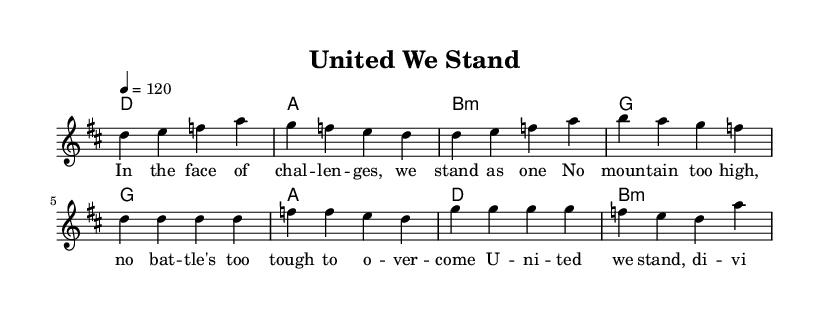What is the key signature of this music? The key signature shown at the beginning of the score is D major, which has two sharps (F# and C#).
Answer: D major What is the time signature of this music? The time signature is indicated in the measure at the start of the music, showing that it is in 4/4 time. This means there are four beats in each measure.
Answer: 4/4 What is the tempo marking for this piece? The tempo is marked as quarter note equals 120, indicating the speed at which the music should be played.
Answer: 120 What is the first chord in the verse? The first chord in the verse section is D, as shown in the chord mode right before the melody starts.
Answer: D How many measures are in the verse? The verse consists of four measures, as indicated by the melody and chord progressions notated within the verse section.
Answer: 4 What themes are addressed in the lyrics? The lyrics mention themes of challenges and unity, expressing the message that together, they can overcome obstacles.
Answer: Challenges and unity How do the chorus lyrics relate to the verse? The chorus emphasizes the importance of teamwork and rising above challenges, reinforcing the message presented in the verse, suggesting a collective effort in overcoming difficulties.
Answer: Teamwork and overcoming 